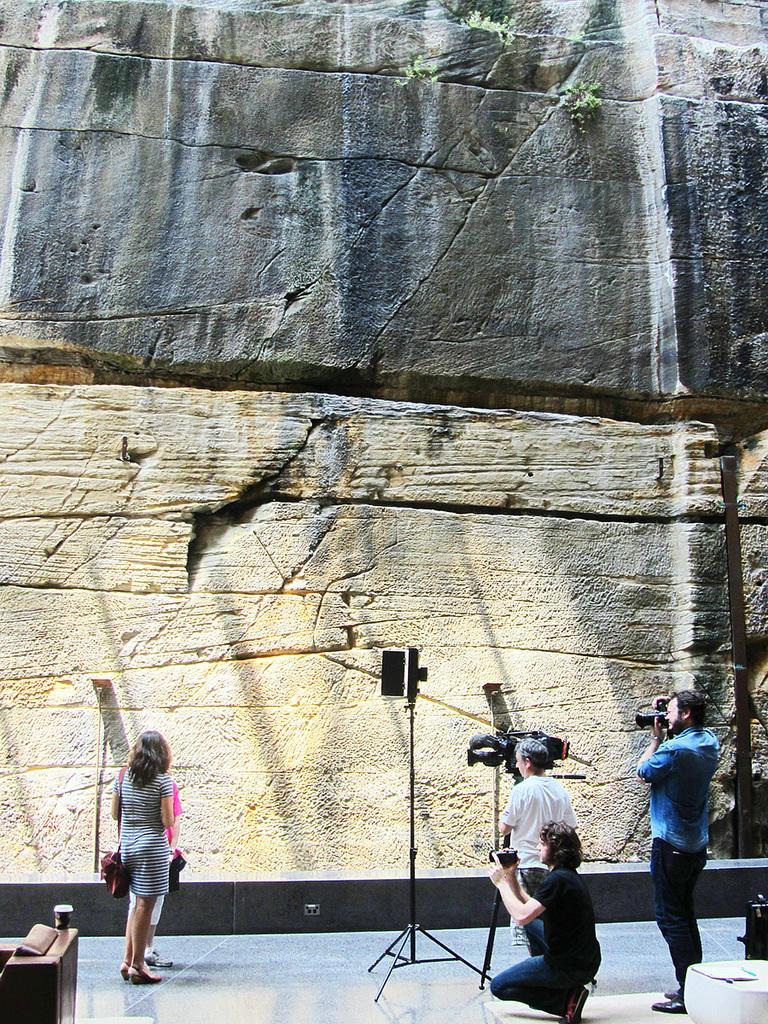Describe this image in one or two sentences. In this image I can see group of people standing and I can see a person holding a camera. The person is wearing blue shirt and blue pant, background I can see the wall in brown and gray color and I can see few plants in green color. 